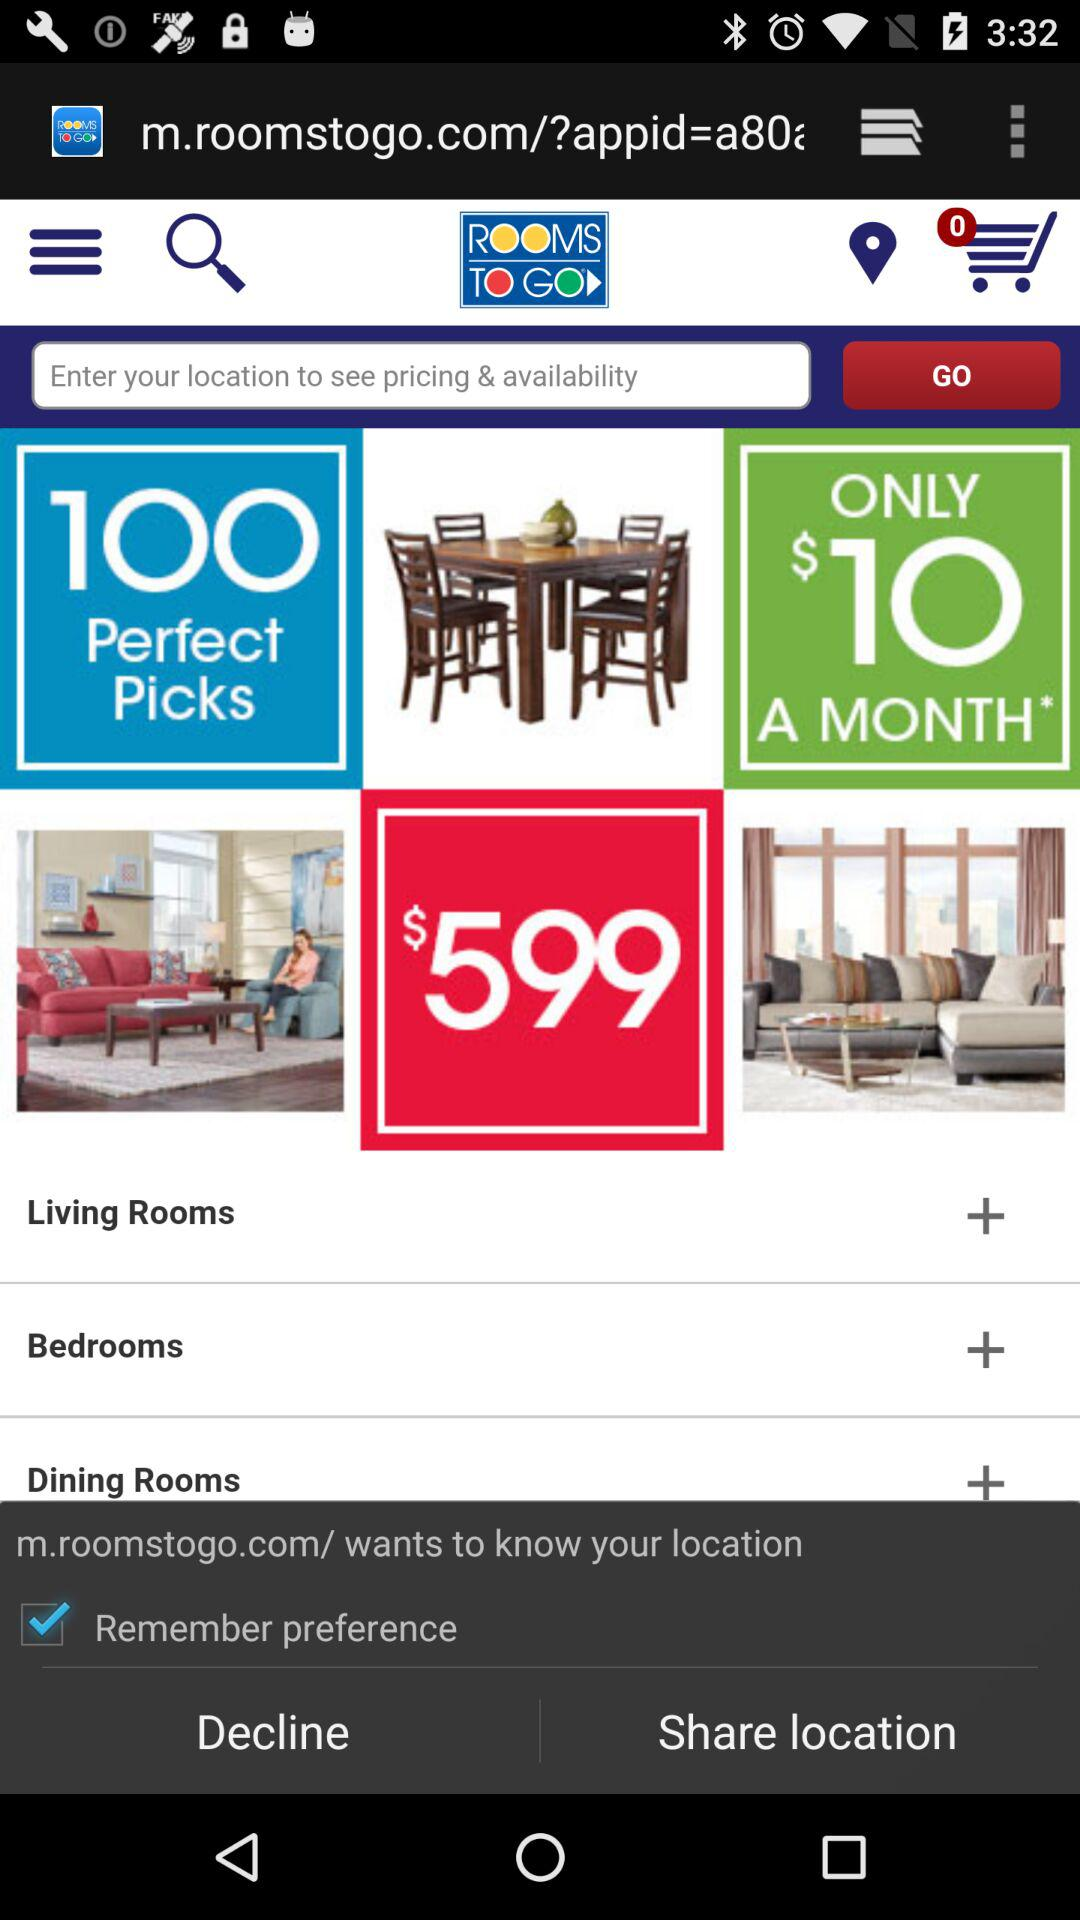What is the number of perfect picks shown in the application? The number of perfect picks shown in the application is 100. 